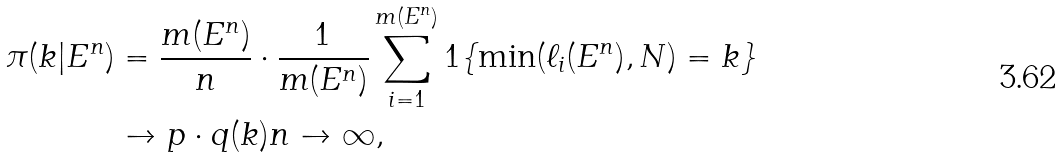Convert formula to latex. <formula><loc_0><loc_0><loc_500><loc_500>\pi ( k | E ^ { n } ) & = \frac { m ( E ^ { n } ) } { n } \cdot \frac { 1 } { m ( E ^ { n } ) } \sum _ { i = 1 } ^ { m ( E ^ { n } ) } 1 \{ \min ( \ell _ { i } ( E ^ { n } ) , N ) = k \} \\ & \to p \cdot q ( k ) n \to \infty ,</formula> 